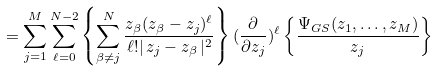<formula> <loc_0><loc_0><loc_500><loc_500>= \sum _ { j = 1 } ^ { M } \sum _ { \ell = 0 } ^ { N - 2 } \left \{ \sum _ { \beta \neq j } ^ { N } \frac { z _ { \beta } ( z _ { \beta } - z _ { j } ) ^ { \ell } } { \ell ! | \, z _ { j } - z _ { \beta } \, | ^ { 2 } } \right \} ( \frac { \partial } { \partial z _ { j } } ) ^ { \ell } \left \{ \frac { \Psi _ { G S } ( z _ { 1 } , \dots , z _ { M } ) } { z _ { j } } \right \}</formula> 